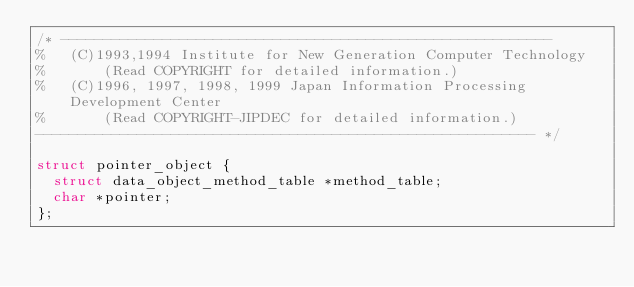Convert code to text. <code><loc_0><loc_0><loc_500><loc_500><_C_>/* ---------------------------------------------------------- 
%   (C)1993,1994 Institute for New Generation Computer Technology 
%       (Read COPYRIGHT for detailed information.) 
%   (C)1996, 1997, 1998, 1999 Japan Information Processing Development Center
%       (Read COPYRIGHT-JIPDEC for detailed information.)
----------------------------------------------------------- */

struct pointer_object {
  struct data_object_method_table *method_table;
  char *pointer;
};
</code> 